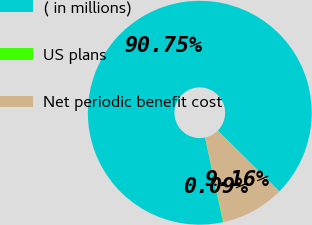<chart> <loc_0><loc_0><loc_500><loc_500><pie_chart><fcel>( in millions)<fcel>US plans<fcel>Net periodic benefit cost<nl><fcel>90.75%<fcel>0.09%<fcel>9.16%<nl></chart> 